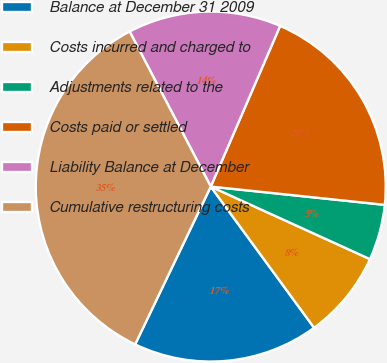Convert chart. <chart><loc_0><loc_0><loc_500><loc_500><pie_chart><fcel>Balance at December 31 2009<fcel>Costs incurred and charged to<fcel>Adjustments related to the<fcel>Costs paid or settled<fcel>Liability Balance at December<fcel>Cumulative restructuring costs<nl><fcel>17.17%<fcel>8.14%<fcel>5.14%<fcel>20.18%<fcel>14.16%<fcel>35.22%<nl></chart> 